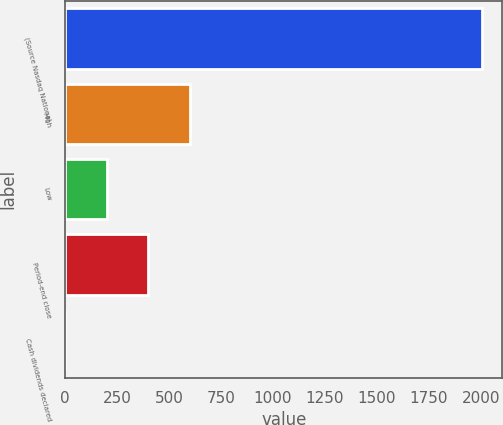Convert chart. <chart><loc_0><loc_0><loc_500><loc_500><bar_chart><fcel>(Source Nasdaq National<fcel>High<fcel>Low<fcel>Period-end close<fcel>Cash dividends declared<nl><fcel>2004<fcel>601.37<fcel>200.63<fcel>401<fcel>0.26<nl></chart> 